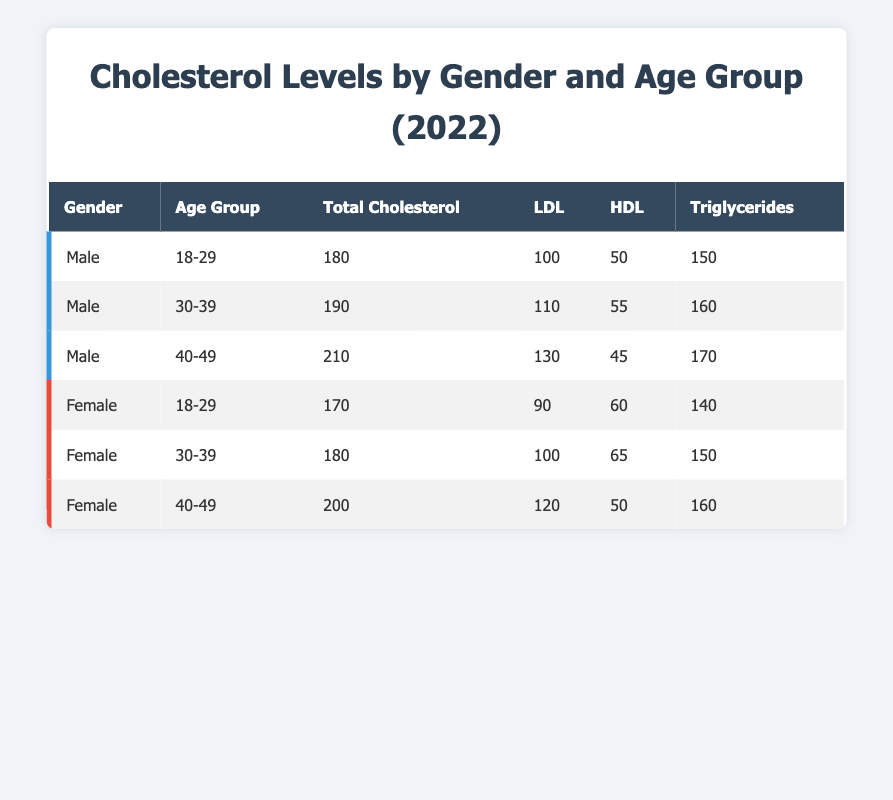What is the total cholesterol level for males aged 30-39? From the table, we can look under the "Male" gender and find the age group "30-39." The total cholesterol level specified for this category is 190.
Answer: 190 What is the LDL level for females aged 40-49? We check the data for "Female" under the age group "40-49." The LDL level for this group is 120.
Answer: 120 Are the triglyceride levels for males generally higher than those for females? To determine this, we can compare the average triglyceride levels for males and females. For males, the triglyceride levels are: 150, 160, and 170, giving an average of (150 + 160 + 170) / 3 = 160. For females, the levels are: 140, 150, and 160 with an average of (140 + 150 + 160) / 3 = 150. Since 160 > 150, the statement is true.
Answer: Yes What is the difference in total cholesterol levels between the youngest male and female age groups? The total cholesterol for the youngest male age group (18-29) is 180, while for females in the same age group it is 170. The difference is calculated as 180 - 170 = 10.
Answer: 10 What is the average HDL level for males in the 30-39 age group? The HDL levels for the ages are: 50 (for 18-29), 55 (for 30-39), and 45 (for 40-49). Therefore, to find the average, we sum up these HDL values: (50 + 55 + 45) and then divide by the number of entries (3): (50 + 55 + 45) / 3 = 150 / 3 = 50.
Answer: 50 Does any female in the 18-29 age group have a triglyceride level over 150? The triglyceride levels for females in the 18-29 age group is 140. Since 140 is not greater than 150, the statement is false.
Answer: No How does the LDL level for males in the 40-49 age group compare to that of females in the same age group? The LDL level for males in the 40-49 age group is 130, while for females it is 120. Therefore, we can conclude that the male LDL level is higher by 130 - 120 = 10.
Answer: 10 What is the average total cholesterol level for all males? The total cholesterol levels for all males are: 180, 190, and 210. To find the average, we sum these levels: 180 + 190 + 210 = 580, and then divide by the number of entries (3): 580 / 3 = approximately 193.33.
Answer: 193.33 How many total cholesterol readings are below 200? From the table, the readings below 200 are: 180, 170, 180, and 190. Therefore, we have four readings below 200.
Answer: 4 